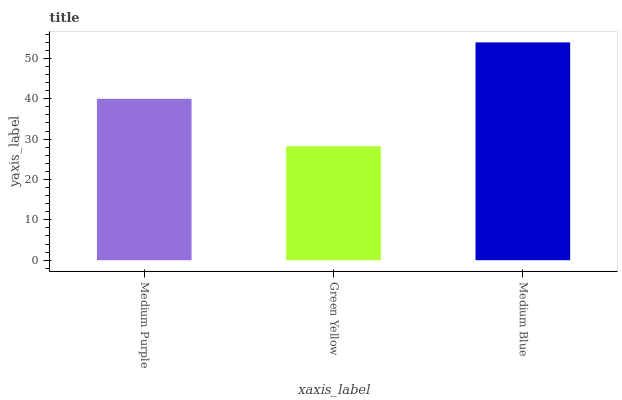Is Green Yellow the minimum?
Answer yes or no. Yes. Is Medium Blue the maximum?
Answer yes or no. Yes. Is Medium Blue the minimum?
Answer yes or no. No. Is Green Yellow the maximum?
Answer yes or no. No. Is Medium Blue greater than Green Yellow?
Answer yes or no. Yes. Is Green Yellow less than Medium Blue?
Answer yes or no. Yes. Is Green Yellow greater than Medium Blue?
Answer yes or no. No. Is Medium Blue less than Green Yellow?
Answer yes or no. No. Is Medium Purple the high median?
Answer yes or no. Yes. Is Medium Purple the low median?
Answer yes or no. Yes. Is Green Yellow the high median?
Answer yes or no. No. Is Green Yellow the low median?
Answer yes or no. No. 